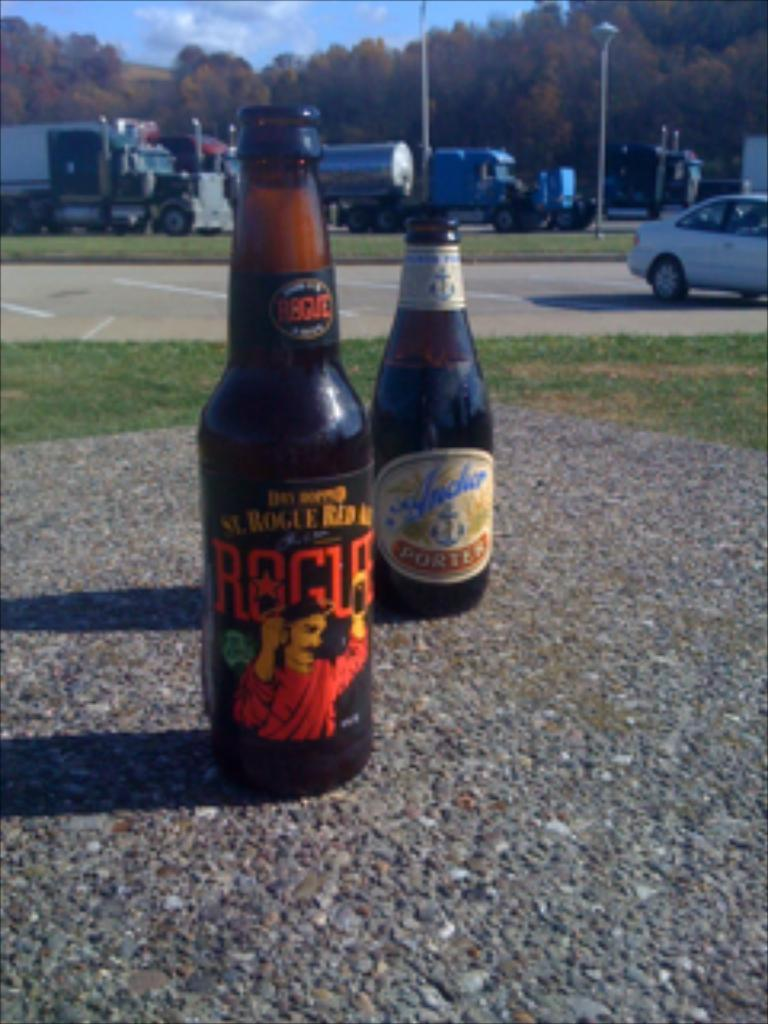What objects can be seen on the road in the foreground? There are two bottles on the road in the foreground. What type of vegetation is present in the foreground? Grass is present in the foreground. What else can be seen in the foreground besides the bottles and grass? Vehicles are visible in the foreground. What can be seen in the background of the image? There are trees, light poles, and the sky visible in the background. Can you determine the time of day the image was taken? The image is likely taken during the day, as the sky is visible and there is no indication of darkness. What word is written on the scarecrow in the image? There is no scarecrow present in the image, so no word can be read on it. 